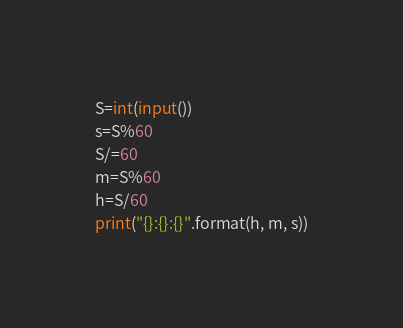Convert code to text. <code><loc_0><loc_0><loc_500><loc_500><_Python_>S=int(input())
s=S%60
S/=60
m=S%60
h=S/60
print("{}:{}:{}".format(h, m, s))</code> 